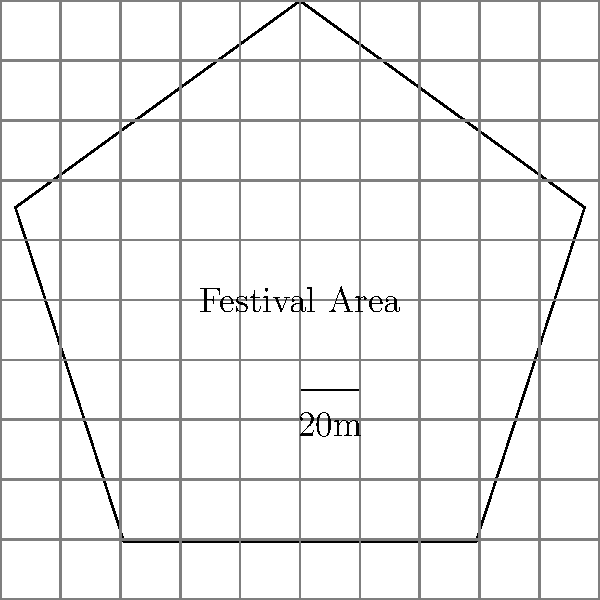At the upcoming Alabama concert, you're tasked with estimating the crowd capacity. The festival area is represented by the pentagon shown in the diagram. If each person requires approximately 0.5 square meters of space, how many people can safely fit in this area? (Note: The scale provided shows 20 meters) To solve this problem, we'll follow these steps:

1. Calculate the side length of the pentagon:
   The scale shows 20 meters for 1 unit in the diagram.
   Each side of the pentagon is 1 unit long in the diagram.
   So, each side of the actual festival area is 20 meters.

2. Calculate the area of the pentagon:
   The formula for the area of a regular pentagon is:
   $$A = \frac{1}{4}\sqrt{5(5+2\sqrt{5})}s^2$$
   where $s$ is the side length.

   Plugging in $s = 20$:
   $$A = \frac{1}{4}\sqrt{5(5+2\sqrt{5})}20^2$$
   $$A \approx 688.19 \text{ square meters}$$

3. Calculate the number of people that can fit:
   Each person requires 0.5 square meters.
   Number of people = Total area / Area per person
   $$\text{Number of people} = \frac{688.19}{0.5} \approx 1376.38$$

4. Round down to ensure safety:
   The safe capacity would be 1376 people.
Answer: 1376 people 